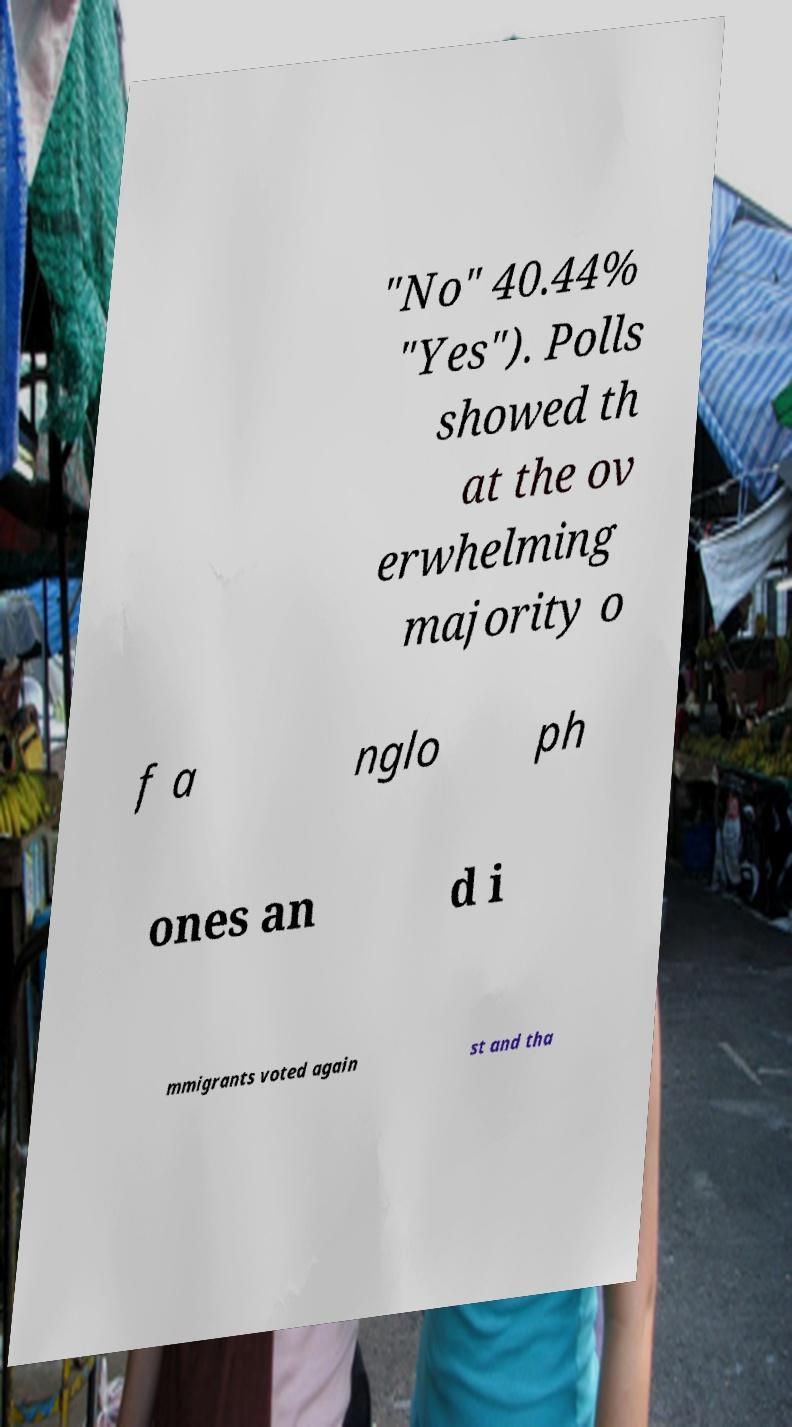There's text embedded in this image that I need extracted. Can you transcribe it verbatim? "No" 40.44% "Yes"). Polls showed th at the ov erwhelming majority o f a nglo ph ones an d i mmigrants voted again st and tha 